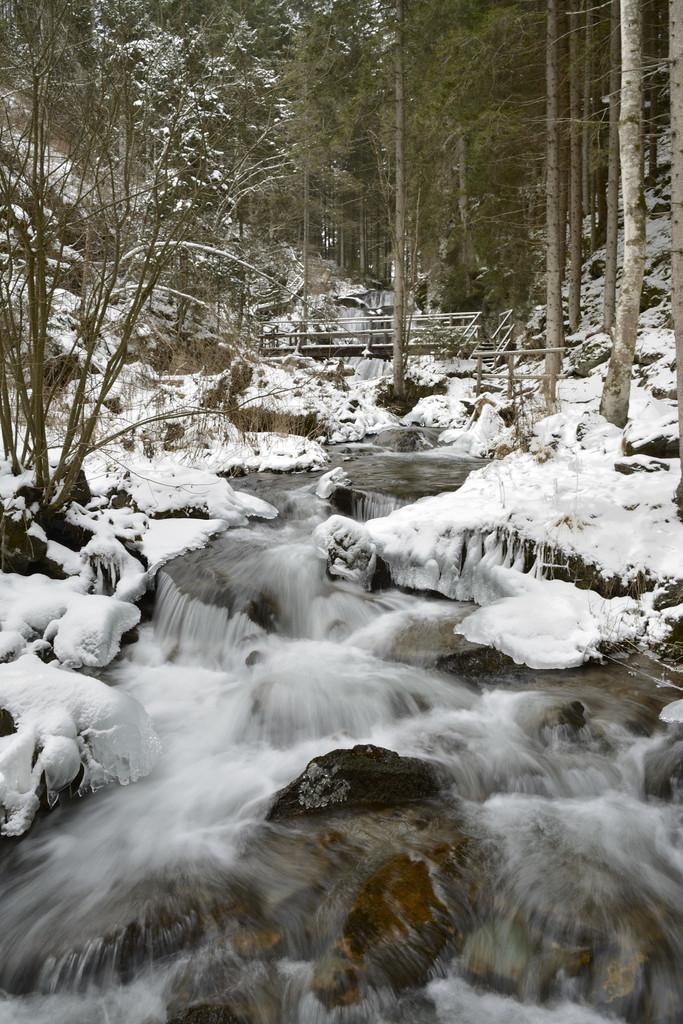In one or two sentences, can you explain what this image depicts? In this picture there are trees and there is a mountain. At the bottom there is water and there is snow. At the back it looks like a bridge. 